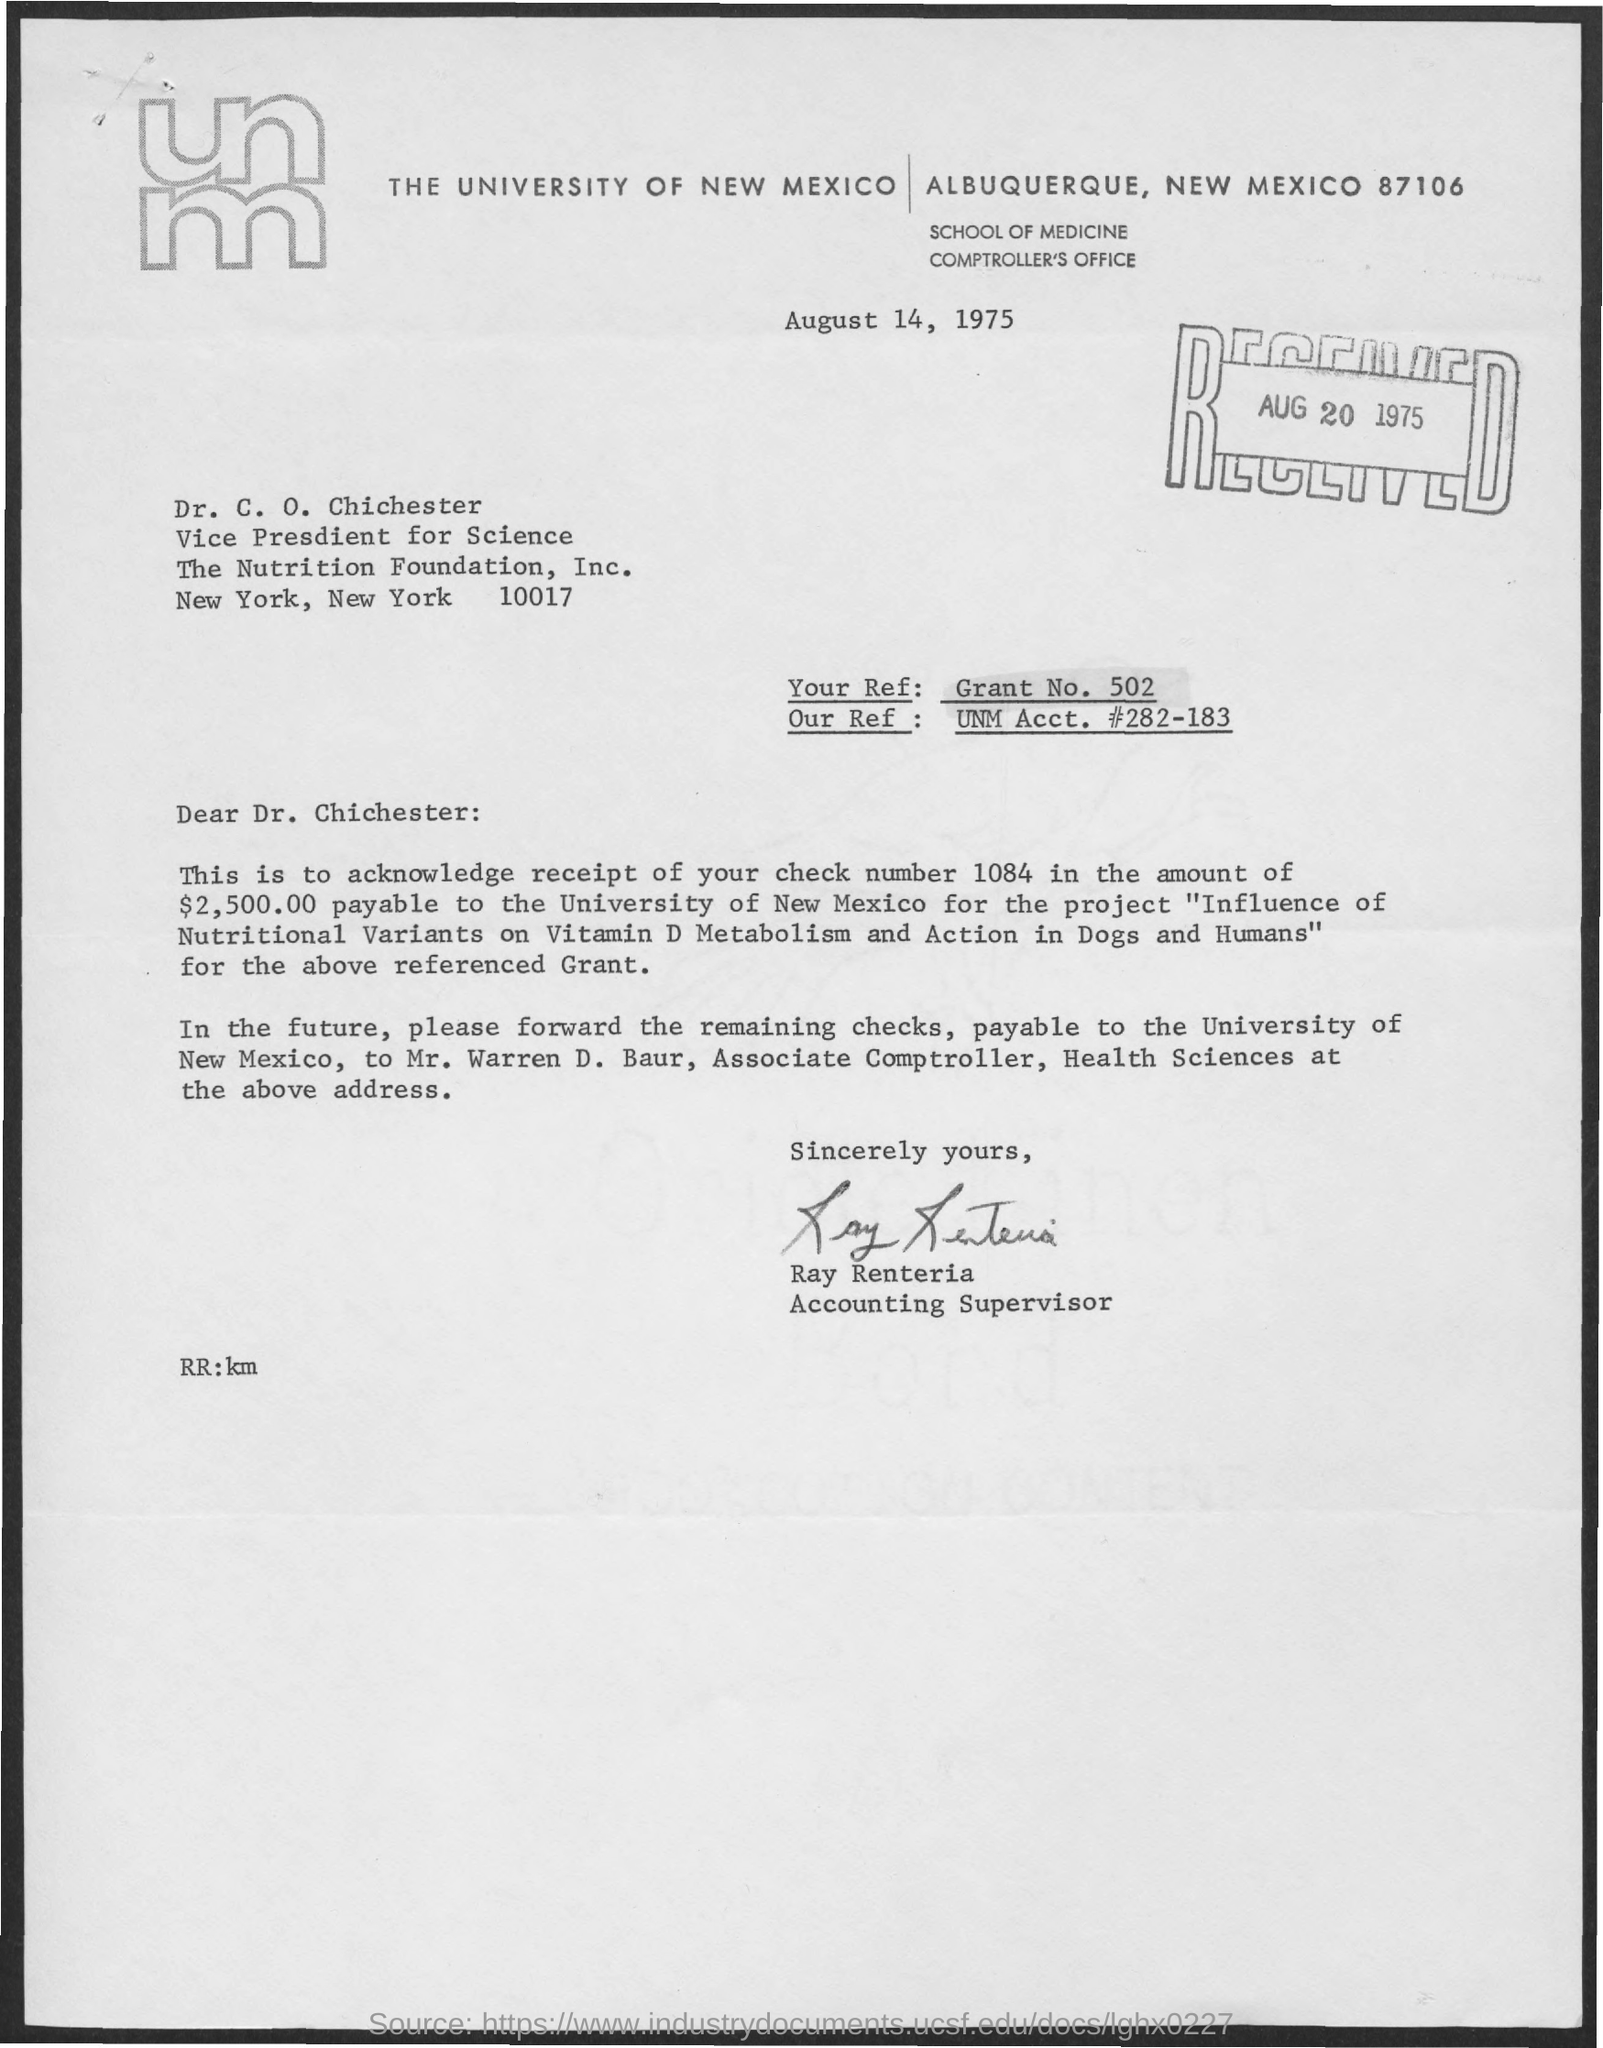What is the date on the document?
Offer a terse response. August 14, 1975. What date was the letter received?
Offer a terse response. August 20 1975. What is "Your Ref:"?
Offer a very short reply. Grant No. 502. What is "Our Ref:"?
Offer a very short reply. UNM Acct. #282-183. To Whom is this letter addressed to?
Provide a succinct answer. Dr. C. O. Chichester. What is the Check Number?
Your answer should be very brief. 1084. What is the Amount Payable to University of New Mexico?
Your answer should be compact. $2,500.00. Who is this letter from?
Give a very brief answer. Ray Renteria. 